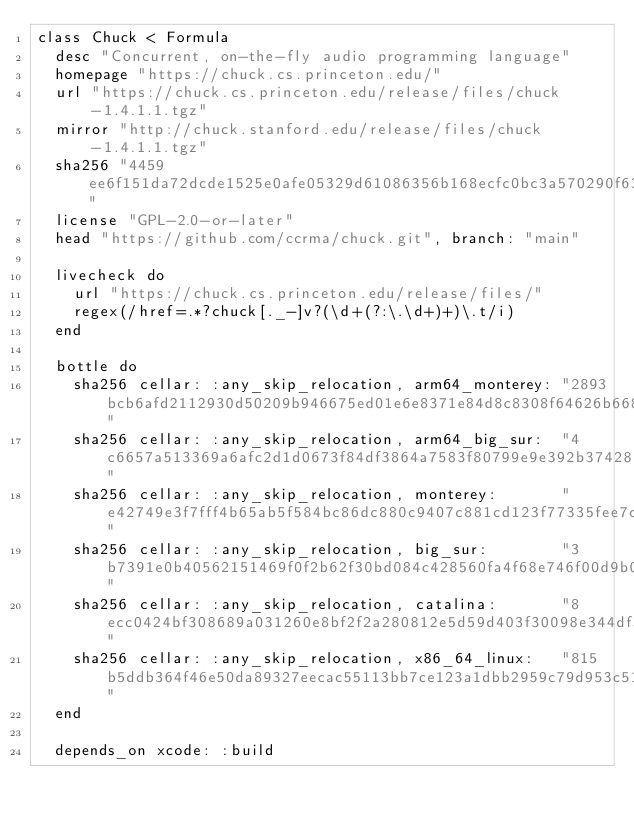Convert code to text. <code><loc_0><loc_0><loc_500><loc_500><_Ruby_>class Chuck < Formula
  desc "Concurrent, on-the-fly audio programming language"
  homepage "https://chuck.cs.princeton.edu/"
  url "https://chuck.cs.princeton.edu/release/files/chuck-1.4.1.1.tgz"
  mirror "http://chuck.stanford.edu/release/files/chuck-1.4.1.1.tgz"
  sha256 "4459ee6f151da72dcde1525e0afe05329d61086356b168ecfc0bc3a570290f63"
  license "GPL-2.0-or-later"
  head "https://github.com/ccrma/chuck.git", branch: "main"

  livecheck do
    url "https://chuck.cs.princeton.edu/release/files/"
    regex(/href=.*?chuck[._-]v?(\d+(?:\.\d+)+)\.t/i)
  end

  bottle do
    sha256 cellar: :any_skip_relocation, arm64_monterey: "2893bcb6afd2112930d50209b946675ed01e6e8371e84d8c8308f64626b66897"
    sha256 cellar: :any_skip_relocation, arm64_big_sur:  "4c6657a513369a6afc2d1d0673f84df3864a7583f80799e9e392b374282fbe90"
    sha256 cellar: :any_skip_relocation, monterey:       "e42749e3f7fff4b65ab5f584bc86dc880c9407c881cd123f77335fee7cb50a41"
    sha256 cellar: :any_skip_relocation, big_sur:        "3b7391e0b40562151469f0f2b62f30bd084c428560fa4f68e746f00d9b022060"
    sha256 cellar: :any_skip_relocation, catalina:       "8ecc0424bf308689a031260e8bf2f2a280812e5d59d403f30098e344df326bcf"
    sha256 cellar: :any_skip_relocation, x86_64_linux:   "815b5ddb364f46e50da89327eecac55113bb7ce123a1dbb2959c79d953c51965"
  end

  depends_on xcode: :build
</code> 